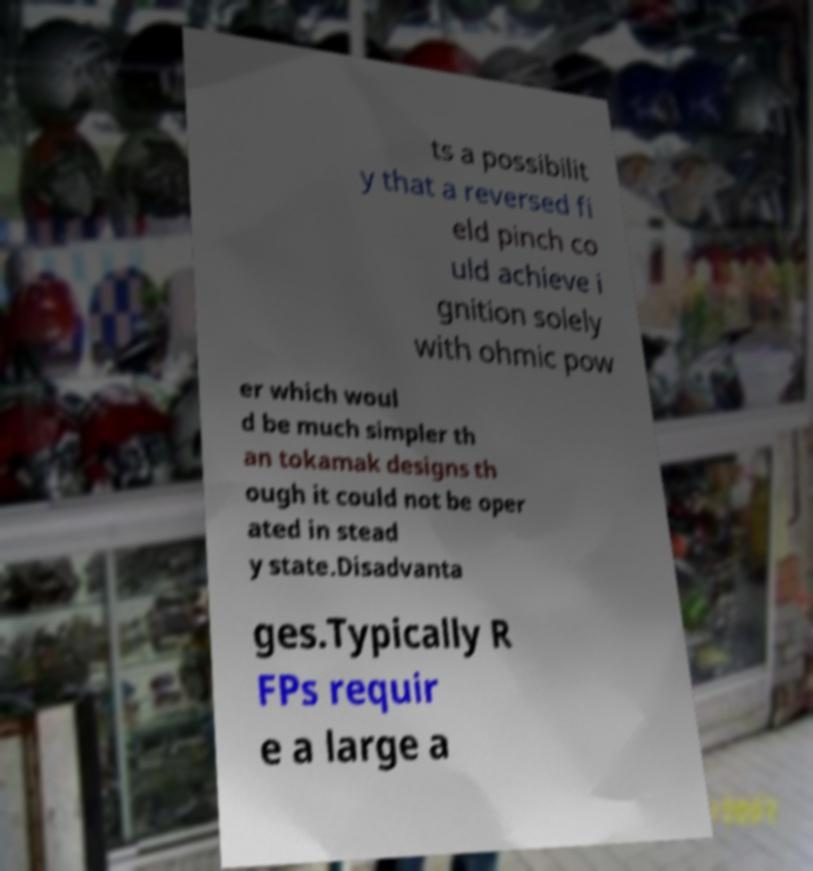I need the written content from this picture converted into text. Can you do that? ts a possibilit y that a reversed fi eld pinch co uld achieve i gnition solely with ohmic pow er which woul d be much simpler th an tokamak designs th ough it could not be oper ated in stead y state.Disadvanta ges.Typically R FPs requir e a large a 